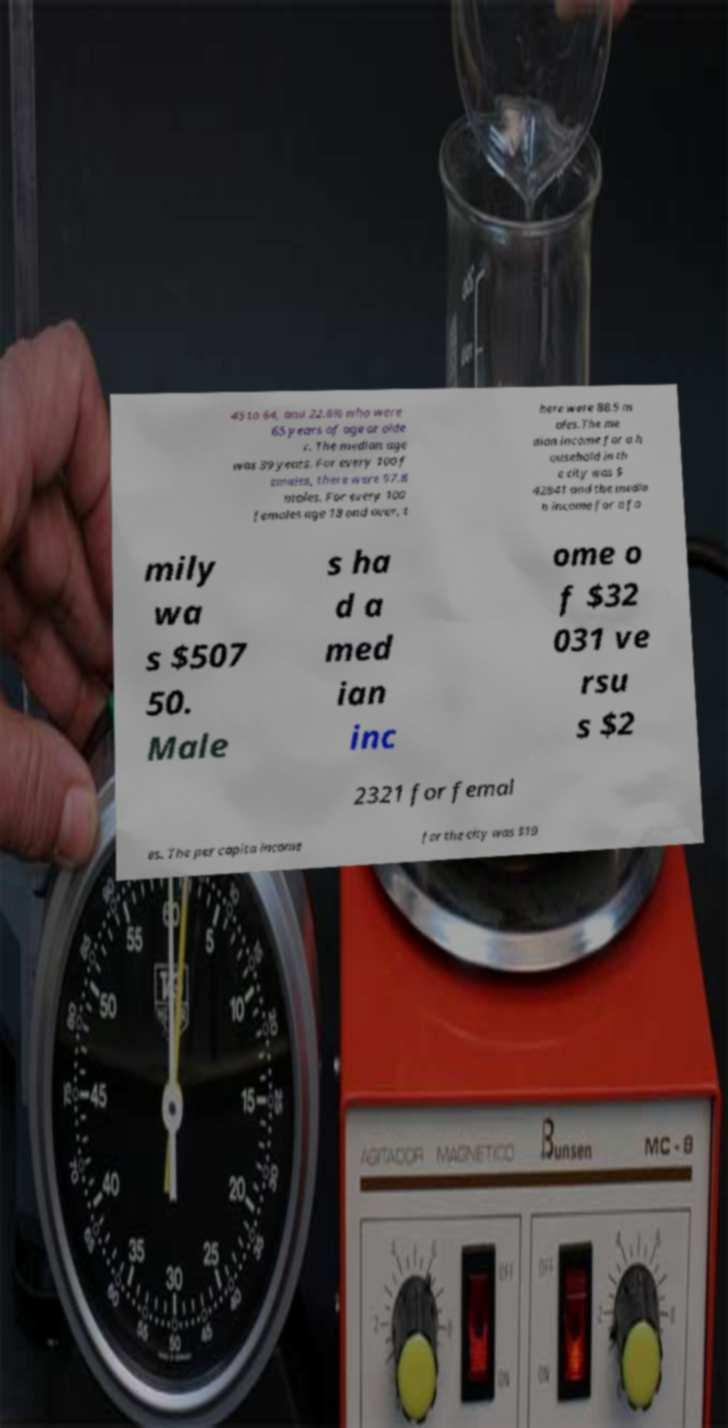Can you accurately transcribe the text from the provided image for me? 45 to 64, and 22.6% who were 65 years of age or olde r. The median age was 39 years. For every 100 f emales, there were 97.8 males. For every 100 females age 18 and over, t here were 88.5 m ales.The me dian income for a h ousehold in th e city was $ 42841 and the media n income for a fa mily wa s $507 50. Male s ha d a med ian inc ome o f $32 031 ve rsu s $2 2321 for femal es. The per capita income for the city was $19 